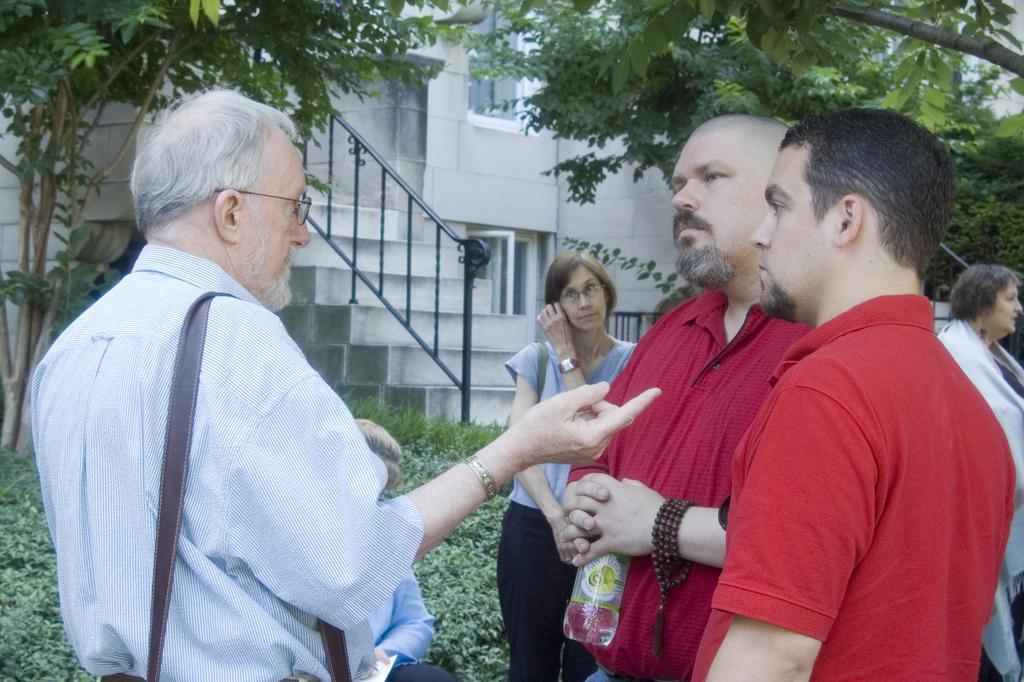Could you give a brief overview of what you see in this image? In the middle of the image few people are standing. Behind them there are some plants and trees and building. 